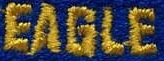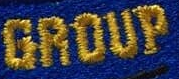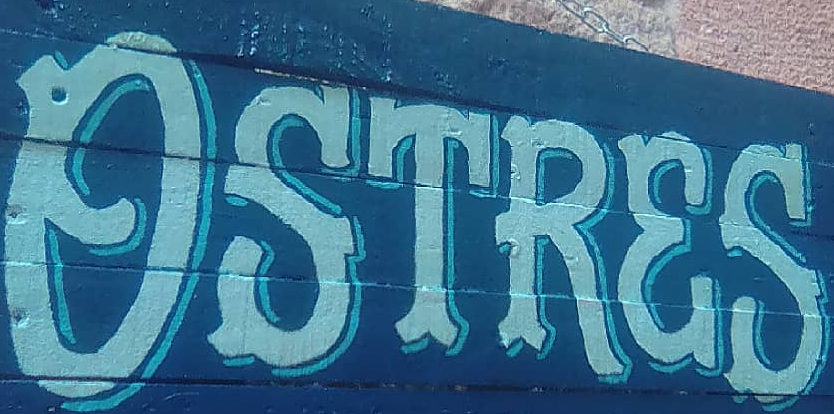Read the text from these images in sequence, separated by a semicolon. EAGLE; GROUP; OSTRES 